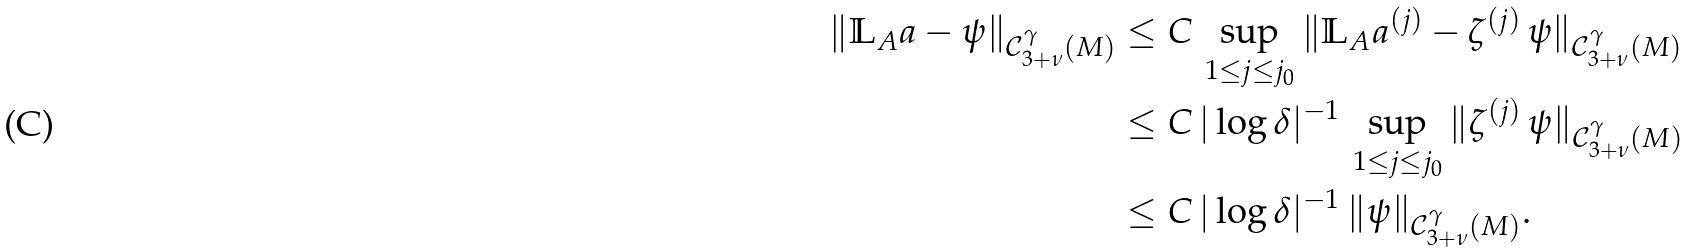Convert formula to latex. <formula><loc_0><loc_0><loc_500><loc_500>\| \mathbb { L } _ { A } a - \psi \| _ { \mathcal { C } _ { 3 + \nu } ^ { \gamma } ( M ) } & \leq C \, \sup _ { 1 \leq j \leq j _ { 0 } } \| \mathbb { L } _ { A } a ^ { ( j ) } - \zeta ^ { ( j ) } \, \psi \| _ { \mathcal { C } _ { 3 + \nu } ^ { \gamma } ( M ) } \\ & \leq C \, | \log \delta | ^ { - 1 } \, \sup _ { 1 \leq j \leq j _ { 0 } } \| \zeta ^ { ( j ) } \, \psi \| _ { \mathcal { C } _ { 3 + \nu } ^ { \gamma } ( M ) } \\ & \leq C \, | \log \delta | ^ { - 1 } \, \| \psi \| _ { \mathcal { C } _ { 3 + \nu } ^ { \gamma } ( M ) } .</formula> 